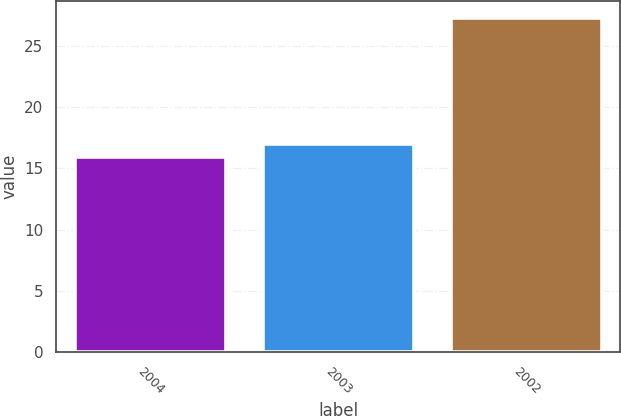Convert chart. <chart><loc_0><loc_0><loc_500><loc_500><bar_chart><fcel>2004<fcel>2003<fcel>2002<nl><fcel>15.9<fcel>17.04<fcel>27.3<nl></chart> 